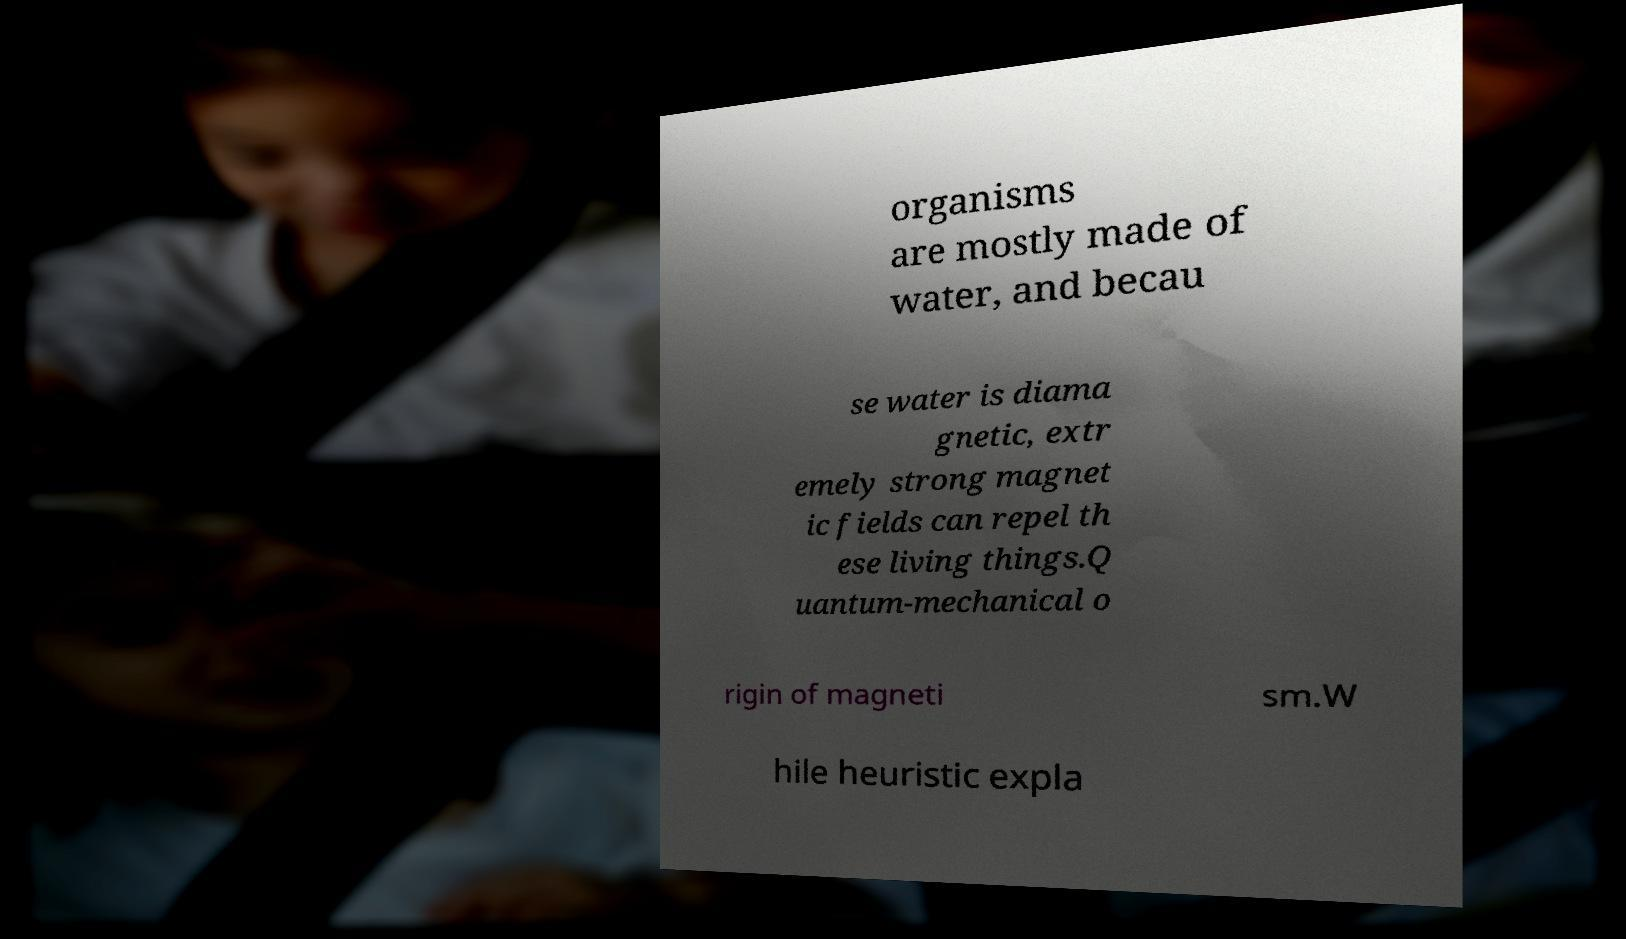What messages or text are displayed in this image? I need them in a readable, typed format. organisms are mostly made of water, and becau se water is diama gnetic, extr emely strong magnet ic fields can repel th ese living things.Q uantum-mechanical o rigin of magneti sm.W hile heuristic expla 